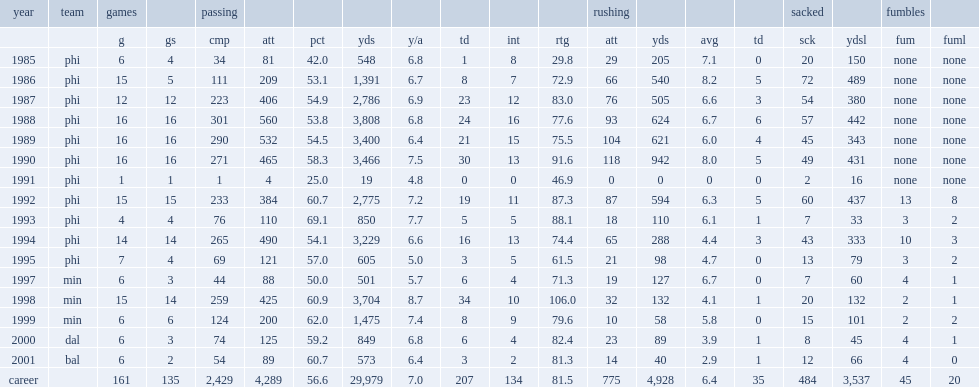How many sacked yards did randall cunningham get in 1988. 442.0. How many yards passing did randall cunningham have in 2000? 849.0. 